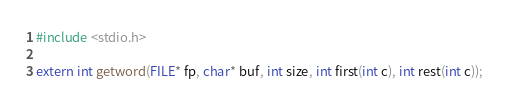Convert code to text. <code><loc_0><loc_0><loc_500><loc_500><_C_>#include <stdio.h>

extern int getword(FILE* fp, char* buf, int size, int first(int c), int rest(int c));
</code> 